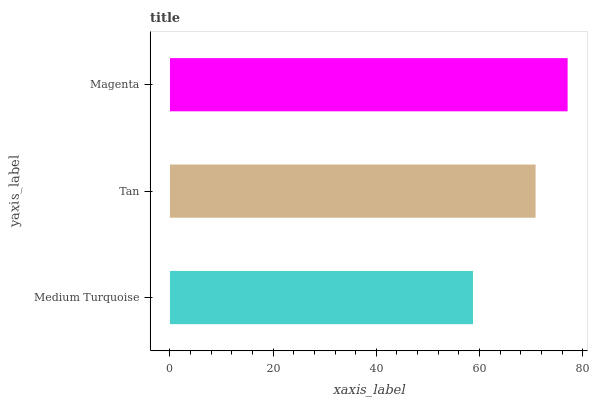Is Medium Turquoise the minimum?
Answer yes or no. Yes. Is Magenta the maximum?
Answer yes or no. Yes. Is Tan the minimum?
Answer yes or no. No. Is Tan the maximum?
Answer yes or no. No. Is Tan greater than Medium Turquoise?
Answer yes or no. Yes. Is Medium Turquoise less than Tan?
Answer yes or no. Yes. Is Medium Turquoise greater than Tan?
Answer yes or no. No. Is Tan less than Medium Turquoise?
Answer yes or no. No. Is Tan the high median?
Answer yes or no. Yes. Is Tan the low median?
Answer yes or no. Yes. Is Medium Turquoise the high median?
Answer yes or no. No. Is Medium Turquoise the low median?
Answer yes or no. No. 